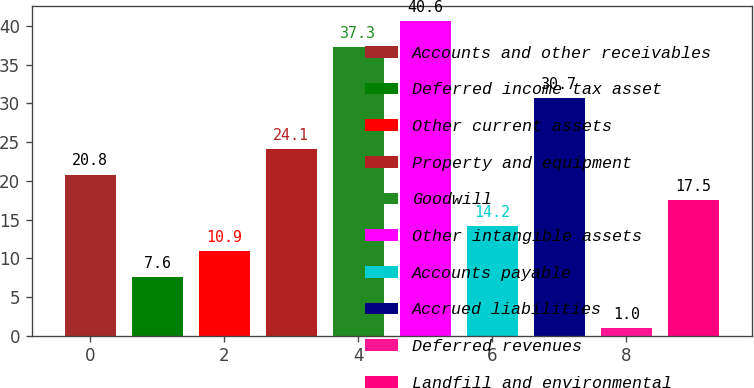<chart> <loc_0><loc_0><loc_500><loc_500><bar_chart><fcel>Accounts and other receivables<fcel>Deferred income tax asset<fcel>Other current assets<fcel>Property and equipment<fcel>Goodwill<fcel>Other intangible assets<fcel>Accounts payable<fcel>Accrued liabilities<fcel>Deferred revenues<fcel>Landfill and environmental<nl><fcel>20.8<fcel>7.6<fcel>10.9<fcel>24.1<fcel>37.3<fcel>40.6<fcel>14.2<fcel>30.7<fcel>1<fcel>17.5<nl></chart> 